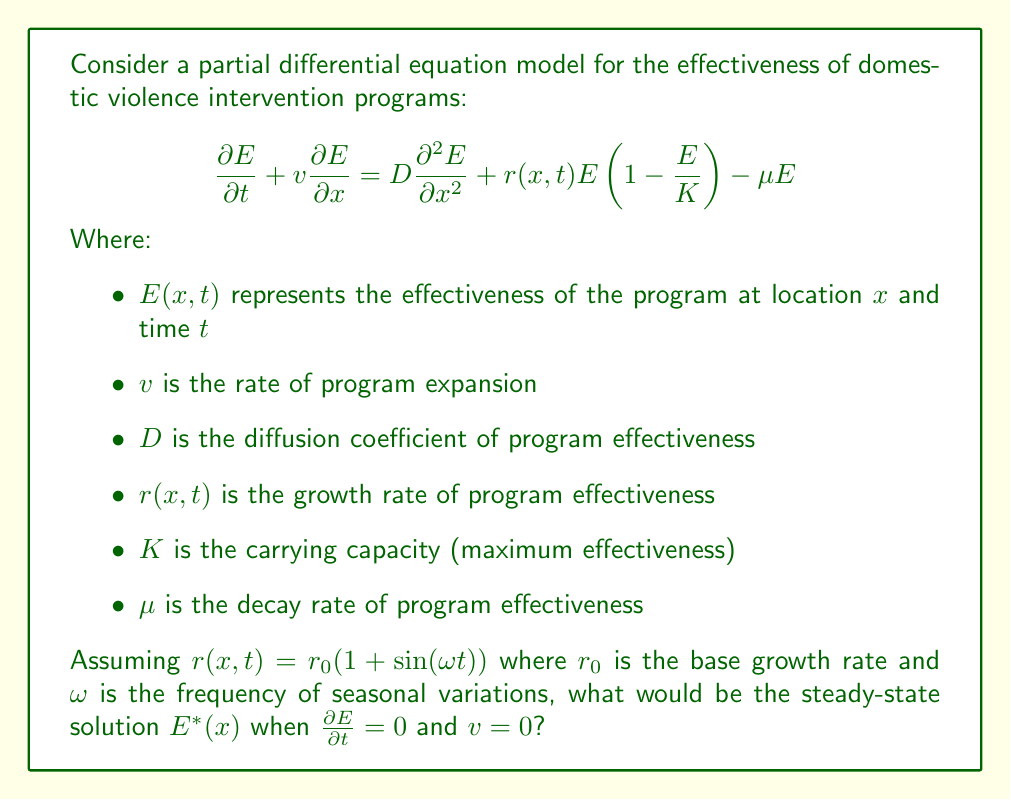Teach me how to tackle this problem. To solve this problem, we need to follow these steps:

1) First, we set $\frac{\partial E}{\partial t} = 0$ and $v = 0$ to find the steady-state solution. This gives us:

   $$0 = D\frac{d^2 E^*}{dx^2} + r(x,t)E^*(1-\frac{E^*}{K}) - \mu E^*$$

2) We're looking for a spatially homogeneous solution, so $\frac{d^2 E^*}{dx^2} = 0$. This simplifies our equation to:

   $$0 = r(x,t)E^*(1-\frac{E^*}{K}) - \mu E^*$$

3) Factoring out $E^*$:

   $$E^*[r(x,t)(1-\frac{E^*}{K}) - \mu] = 0$$

4) This equation is satisfied when either $E^* = 0$ or when the term in brackets is zero. The non-zero solution comes from solving:

   $$r(x,t)(1-\frac{E^*}{K}) - \mu = 0$$

5) Solving for $E^*$:

   $$E^* = K(1 - \frac{\mu}{r(x,t)})$$

6) Now, we need to consider the time-averaged behavior of $r(x,t)$. Over a long period, the average value of $\sin(\omega t)$ is zero, so the time-averaged $r(x,t)$ is simply $r_0$. 

7) Therefore, the steady-state solution is:

   $$E^* = K(1 - \frac{\mu}{r_0})$$

This solution is only valid when $r_0 > \mu$, otherwise $E^*$ would be negative, which is not meaningful in this context.
Answer: The steady-state solution is $E^* = K(1 - \frac{\mu}{r_0})$, where $K$ is the carrying capacity, $\mu$ is the decay rate, and $r_0$ is the base growth rate of program effectiveness. This solution is valid only when $r_0 > \mu$. 